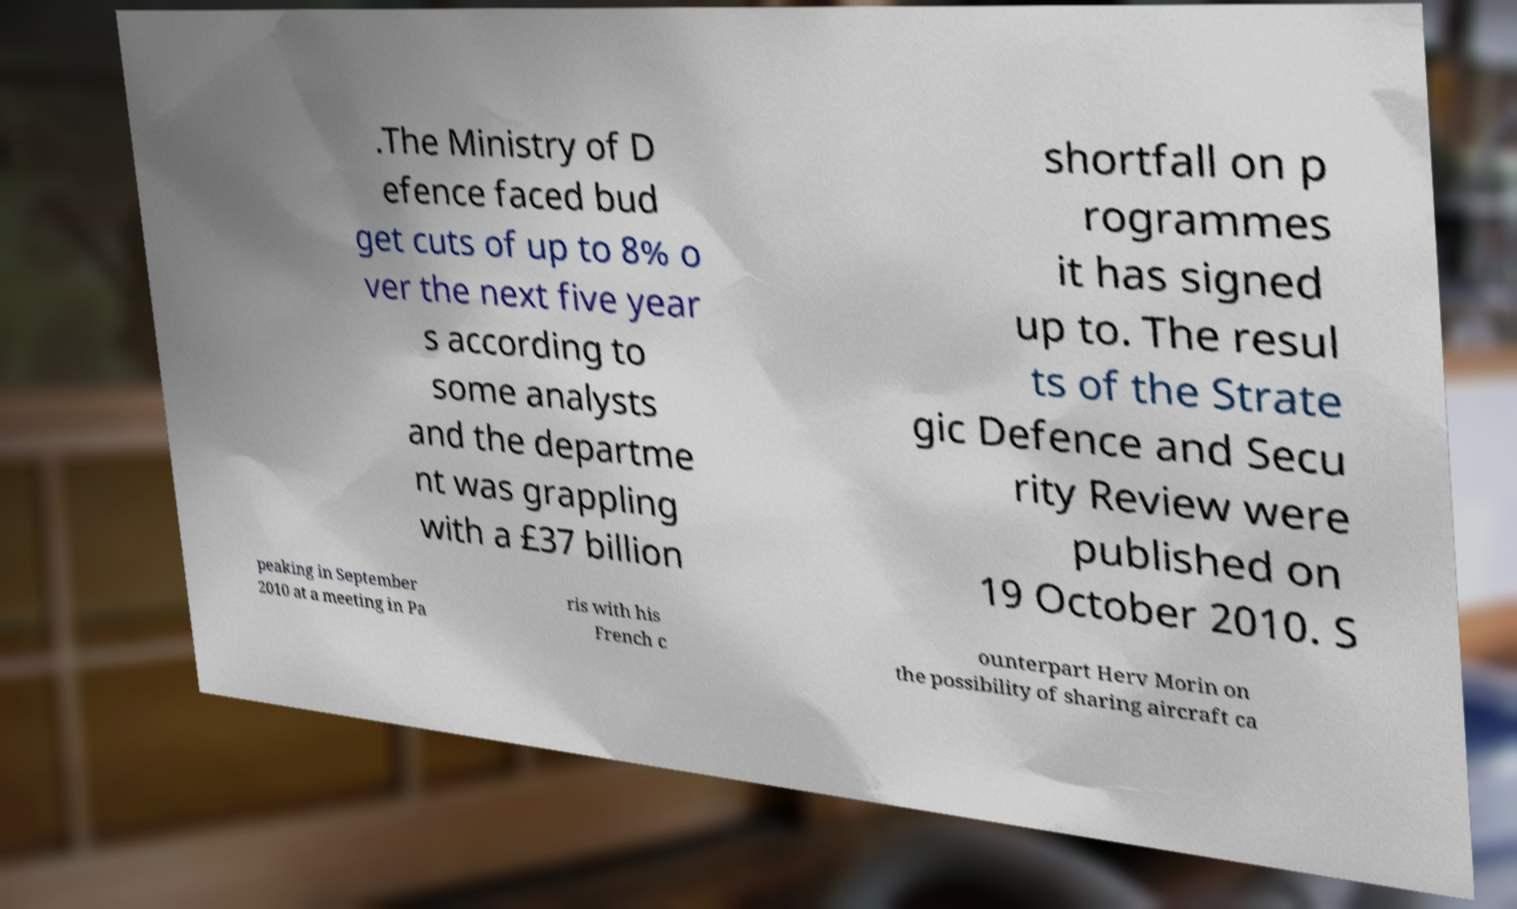Please identify and transcribe the text found in this image. .The Ministry of D efence faced bud get cuts of up to 8% o ver the next five year s according to some analysts and the departme nt was grappling with a £37 billion shortfall on p rogrammes it has signed up to. The resul ts of the Strate gic Defence and Secu rity Review were published on 19 October 2010. S peaking in September 2010 at a meeting in Pa ris with his French c ounterpart Herv Morin on the possibility of sharing aircraft ca 